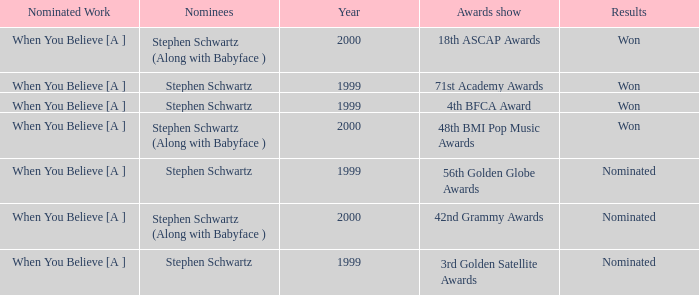Which Nominated Work won in 2000? When You Believe [A ], When You Believe [A ]. Parse the full table. {'header': ['Nominated Work', 'Nominees', 'Year', 'Awards show', 'Results'], 'rows': [['When You Believe [A ]', 'Stephen Schwartz (Along with Babyface )', '2000', '18th ASCAP Awards', 'Won'], ['When You Believe [A ]', 'Stephen Schwartz', '1999', '71st Academy Awards', 'Won'], ['When You Believe [A ]', 'Stephen Schwartz', '1999', '4th BFCA Award', 'Won'], ['When You Believe [A ]', 'Stephen Schwartz (Along with Babyface )', '2000', '48th BMI Pop Music Awards', 'Won'], ['When You Believe [A ]', 'Stephen Schwartz', '1999', '56th Golden Globe Awards', 'Nominated'], ['When You Believe [A ]', 'Stephen Schwartz (Along with Babyface )', '2000', '42nd Grammy Awards', 'Nominated'], ['When You Believe [A ]', 'Stephen Schwartz', '1999', '3rd Golden Satellite Awards', 'Nominated']]} 